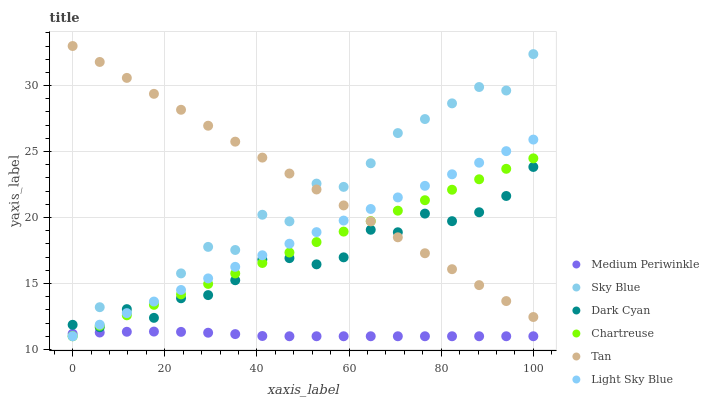Does Medium Periwinkle have the minimum area under the curve?
Answer yes or no. Yes. Does Tan have the maximum area under the curve?
Answer yes or no. Yes. Does Chartreuse have the minimum area under the curve?
Answer yes or no. No. Does Chartreuse have the maximum area under the curve?
Answer yes or no. No. Is Chartreuse the smoothest?
Answer yes or no. Yes. Is Sky Blue the roughest?
Answer yes or no. Yes. Is Light Sky Blue the smoothest?
Answer yes or no. No. Is Light Sky Blue the roughest?
Answer yes or no. No. Does Medium Periwinkle have the lowest value?
Answer yes or no. Yes. Does Dark Cyan have the lowest value?
Answer yes or no. No. Does Tan have the highest value?
Answer yes or no. Yes. Does Chartreuse have the highest value?
Answer yes or no. No. Is Medium Periwinkle less than Tan?
Answer yes or no. Yes. Is Dark Cyan greater than Medium Periwinkle?
Answer yes or no. Yes. Does Tan intersect Dark Cyan?
Answer yes or no. Yes. Is Tan less than Dark Cyan?
Answer yes or no. No. Is Tan greater than Dark Cyan?
Answer yes or no. No. Does Medium Periwinkle intersect Tan?
Answer yes or no. No. 